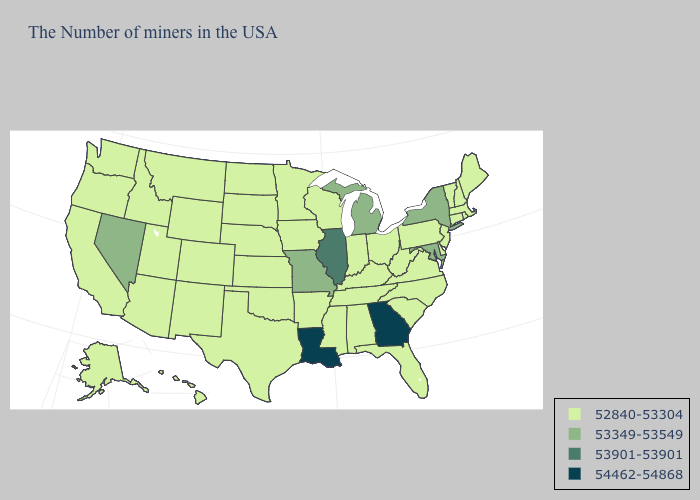Among the states that border Kansas , does Oklahoma have the highest value?
Concise answer only. No. What is the lowest value in the USA?
Keep it brief. 52840-53304. How many symbols are there in the legend?
Quick response, please. 4. What is the lowest value in states that border Arizona?
Keep it brief. 52840-53304. Name the states that have a value in the range 53901-53901?
Keep it brief. Illinois. Name the states that have a value in the range 52840-53304?
Keep it brief. Maine, Massachusetts, Rhode Island, New Hampshire, Vermont, Connecticut, New Jersey, Delaware, Pennsylvania, Virginia, North Carolina, South Carolina, West Virginia, Ohio, Florida, Kentucky, Indiana, Alabama, Tennessee, Wisconsin, Mississippi, Arkansas, Minnesota, Iowa, Kansas, Nebraska, Oklahoma, Texas, South Dakota, North Dakota, Wyoming, Colorado, New Mexico, Utah, Montana, Arizona, Idaho, California, Washington, Oregon, Alaska, Hawaii. Name the states that have a value in the range 53349-53549?
Give a very brief answer. New York, Maryland, Michigan, Missouri, Nevada. What is the highest value in states that border Vermont?
Be succinct. 53349-53549. Does the map have missing data?
Keep it brief. No. Is the legend a continuous bar?
Write a very short answer. No. Which states have the highest value in the USA?
Write a very short answer. Georgia, Louisiana. Name the states that have a value in the range 53901-53901?
Give a very brief answer. Illinois. What is the value of Hawaii?
Concise answer only. 52840-53304. What is the value of South Carolina?
Be succinct. 52840-53304. What is the highest value in the South ?
Quick response, please. 54462-54868. 